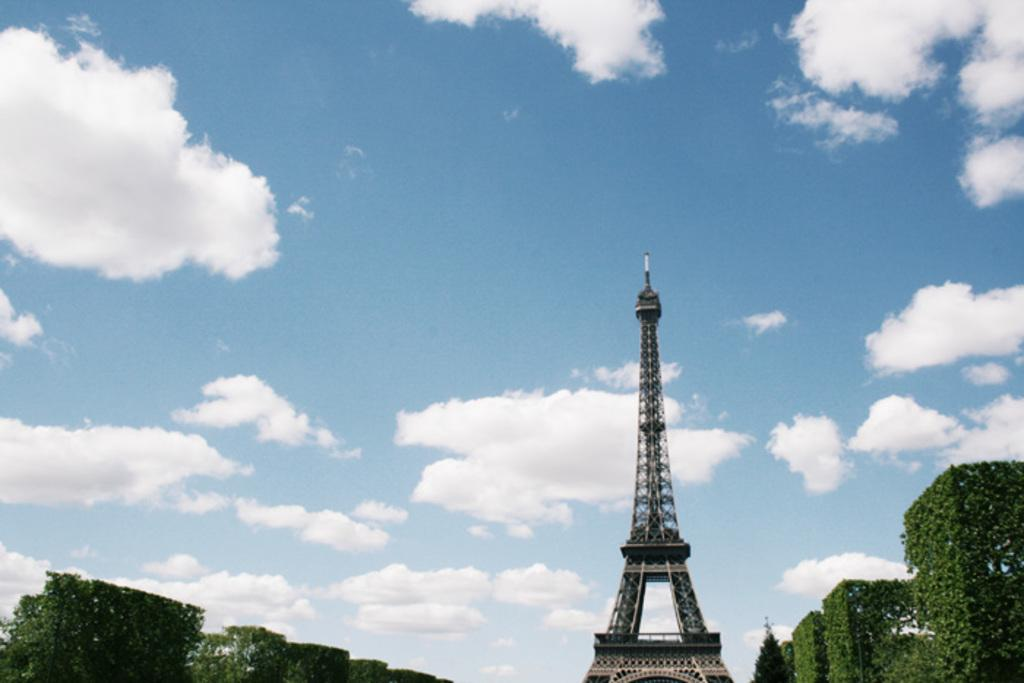What is the main subject of the picture? The main subject of the picture is the Eiffel tower. What can be seen on the ground on either side of the picture? There are plants on the ground on either side of the picture. What is visible in the sky in the background of the picture? There are clouds in the sky in the background of the picture. What type of representative can be seen in the picture? There is no representative present in the picture; it features the Eiffel tower, plants, and clouds. Can you tell me how many bees are buzzing around the Eiffel tower in the picture? There are no bees present in the picture; it only features the Eiffel tower, plants, and clouds. 